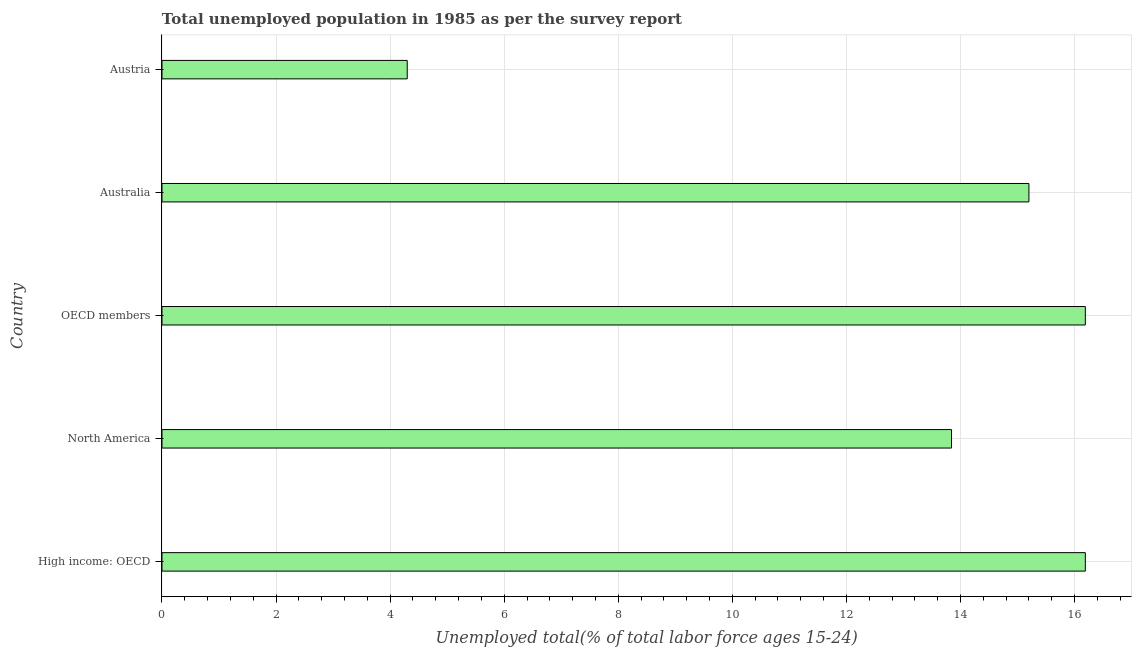What is the title of the graph?
Your response must be concise. Total unemployed population in 1985 as per the survey report. What is the label or title of the X-axis?
Offer a terse response. Unemployed total(% of total labor force ages 15-24). What is the label or title of the Y-axis?
Give a very brief answer. Country. What is the unemployed youth in OECD members?
Offer a very short reply. 16.19. Across all countries, what is the maximum unemployed youth?
Ensure brevity in your answer.  16.19. Across all countries, what is the minimum unemployed youth?
Ensure brevity in your answer.  4.3. In which country was the unemployed youth maximum?
Your answer should be compact. High income: OECD. In which country was the unemployed youth minimum?
Offer a terse response. Austria. What is the sum of the unemployed youth?
Keep it short and to the point. 65.72. What is the difference between the unemployed youth in North America and OECD members?
Offer a terse response. -2.35. What is the average unemployed youth per country?
Provide a succinct answer. 13.14. What is the median unemployed youth?
Provide a succinct answer. 15.2. In how many countries, is the unemployed youth greater than 7.2 %?
Provide a succinct answer. 4. What is the ratio of the unemployed youth in High income: OECD to that in OECD members?
Offer a very short reply. 1. What is the difference between the highest and the second highest unemployed youth?
Provide a short and direct response. 0. Is the sum of the unemployed youth in Australia and OECD members greater than the maximum unemployed youth across all countries?
Your answer should be compact. Yes. What is the difference between the highest and the lowest unemployed youth?
Keep it short and to the point. 11.89. How many countries are there in the graph?
Make the answer very short. 5. Are the values on the major ticks of X-axis written in scientific E-notation?
Give a very brief answer. No. What is the Unemployed total(% of total labor force ages 15-24) of High income: OECD?
Your answer should be very brief. 16.19. What is the Unemployed total(% of total labor force ages 15-24) of North America?
Your response must be concise. 13.84. What is the Unemployed total(% of total labor force ages 15-24) in OECD members?
Give a very brief answer. 16.19. What is the Unemployed total(% of total labor force ages 15-24) of Australia?
Provide a succinct answer. 15.2. What is the Unemployed total(% of total labor force ages 15-24) in Austria?
Keep it short and to the point. 4.3. What is the difference between the Unemployed total(% of total labor force ages 15-24) in High income: OECD and North America?
Offer a terse response. 2.35. What is the difference between the Unemployed total(% of total labor force ages 15-24) in High income: OECD and Australia?
Make the answer very short. 0.99. What is the difference between the Unemployed total(% of total labor force ages 15-24) in High income: OECD and Austria?
Provide a succinct answer. 11.89. What is the difference between the Unemployed total(% of total labor force ages 15-24) in North America and OECD members?
Keep it short and to the point. -2.35. What is the difference between the Unemployed total(% of total labor force ages 15-24) in North America and Australia?
Your answer should be very brief. -1.36. What is the difference between the Unemployed total(% of total labor force ages 15-24) in North America and Austria?
Offer a very short reply. 9.54. What is the difference between the Unemployed total(% of total labor force ages 15-24) in OECD members and Australia?
Keep it short and to the point. 0.99. What is the difference between the Unemployed total(% of total labor force ages 15-24) in OECD members and Austria?
Your answer should be very brief. 11.89. What is the difference between the Unemployed total(% of total labor force ages 15-24) in Australia and Austria?
Make the answer very short. 10.9. What is the ratio of the Unemployed total(% of total labor force ages 15-24) in High income: OECD to that in North America?
Make the answer very short. 1.17. What is the ratio of the Unemployed total(% of total labor force ages 15-24) in High income: OECD to that in Australia?
Your response must be concise. 1.06. What is the ratio of the Unemployed total(% of total labor force ages 15-24) in High income: OECD to that in Austria?
Your response must be concise. 3.77. What is the ratio of the Unemployed total(% of total labor force ages 15-24) in North America to that in OECD members?
Ensure brevity in your answer.  0.85. What is the ratio of the Unemployed total(% of total labor force ages 15-24) in North America to that in Australia?
Provide a succinct answer. 0.91. What is the ratio of the Unemployed total(% of total labor force ages 15-24) in North America to that in Austria?
Make the answer very short. 3.22. What is the ratio of the Unemployed total(% of total labor force ages 15-24) in OECD members to that in Australia?
Provide a short and direct response. 1.06. What is the ratio of the Unemployed total(% of total labor force ages 15-24) in OECD members to that in Austria?
Give a very brief answer. 3.77. What is the ratio of the Unemployed total(% of total labor force ages 15-24) in Australia to that in Austria?
Give a very brief answer. 3.54. 